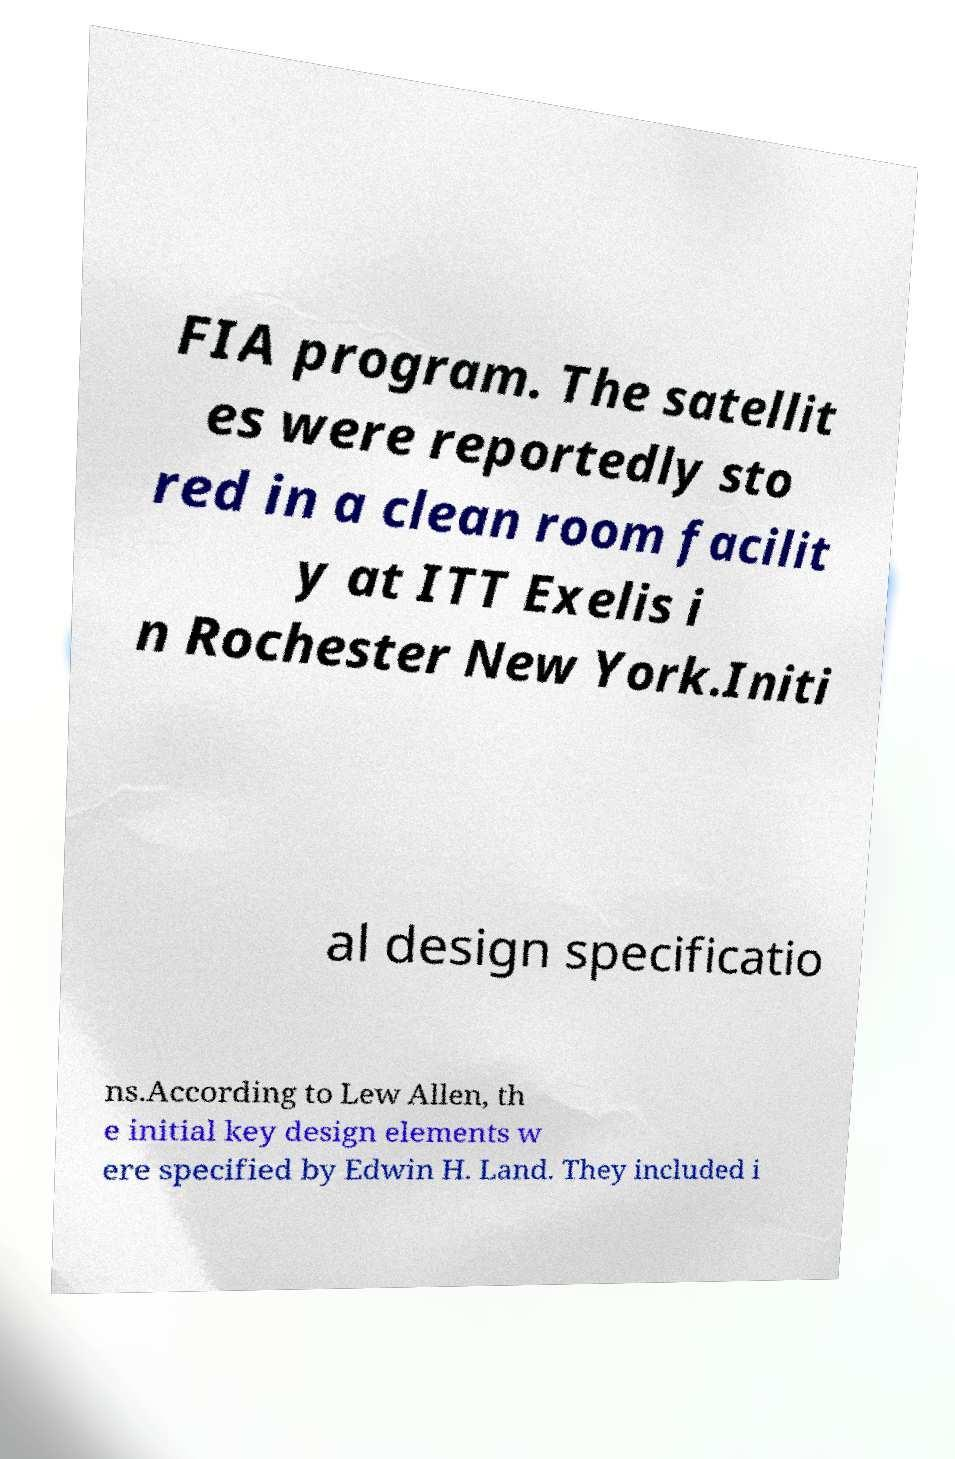Could you assist in decoding the text presented in this image and type it out clearly? FIA program. The satellit es were reportedly sto red in a clean room facilit y at ITT Exelis i n Rochester New York.Initi al design specificatio ns.According to Lew Allen, th e initial key design elements w ere specified by Edwin H. Land. They included i 